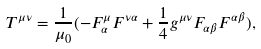<formula> <loc_0><loc_0><loc_500><loc_500>T ^ { \mu \nu } = \frac { 1 } { \mu _ { 0 } } ( - F _ { \alpha } ^ { \mu } F ^ { \nu \alpha } + \frac { 1 } { 4 } g ^ { \mu \nu } F _ { \alpha \beta } F ^ { \alpha \beta } ) ,</formula> 